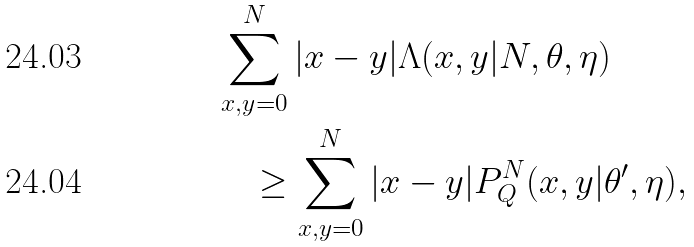Convert formula to latex. <formula><loc_0><loc_0><loc_500><loc_500>& \sum _ { x , y = 0 } ^ { N } | x - y | \Lambda ( x , y | N , \theta , \eta ) \\ & \quad \geq \sum _ { x , y = 0 } ^ { N } | x - y | P _ { Q } ^ { N } ( x , y | \theta ^ { \prime } , \eta ) ,</formula> 